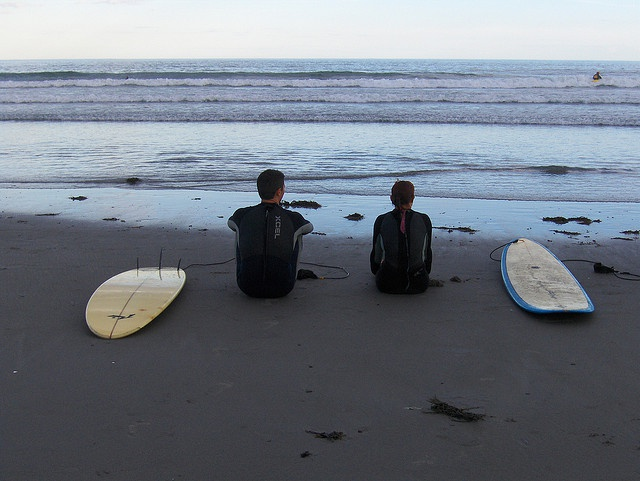Describe the objects in this image and their specific colors. I can see people in ivory, black, gray, maroon, and darkblue tones, people in white, black, purple, maroon, and lightblue tones, surfboard in white, darkgray, blue, gray, and black tones, surfboard in white, darkgray, tan, lightgray, and gray tones, and people in white, navy, black, gray, and maroon tones in this image. 